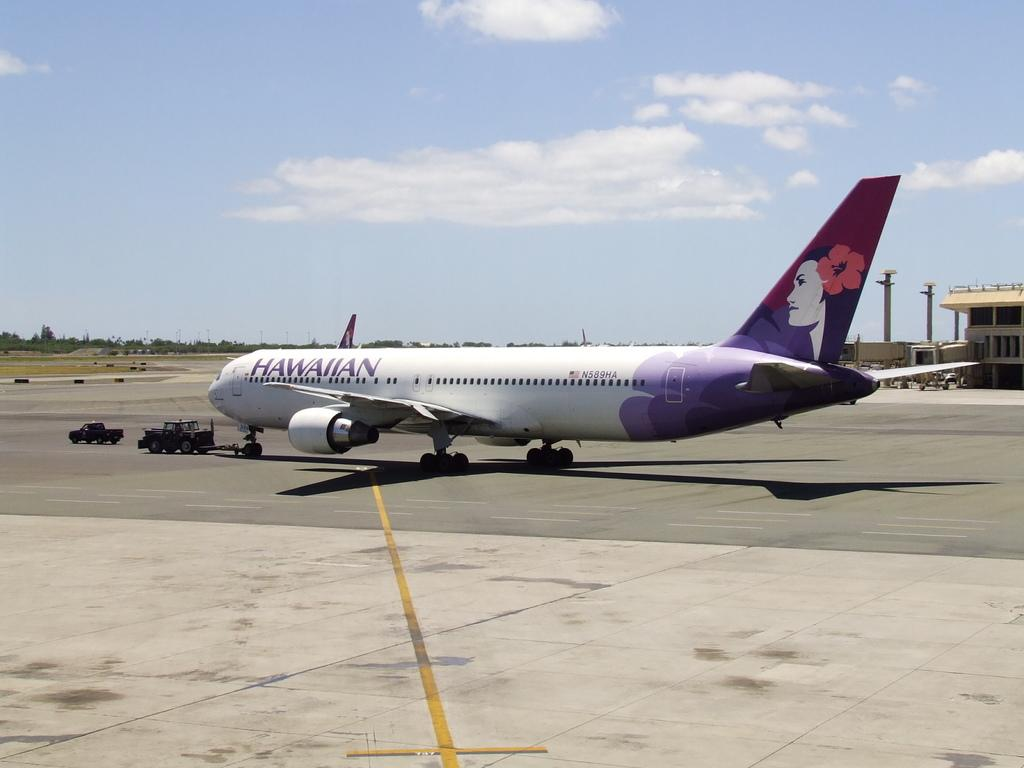<image>
Offer a succinct explanation of the picture presented. An Hawaiian airlines jet sits on the tarmac at an airport. 